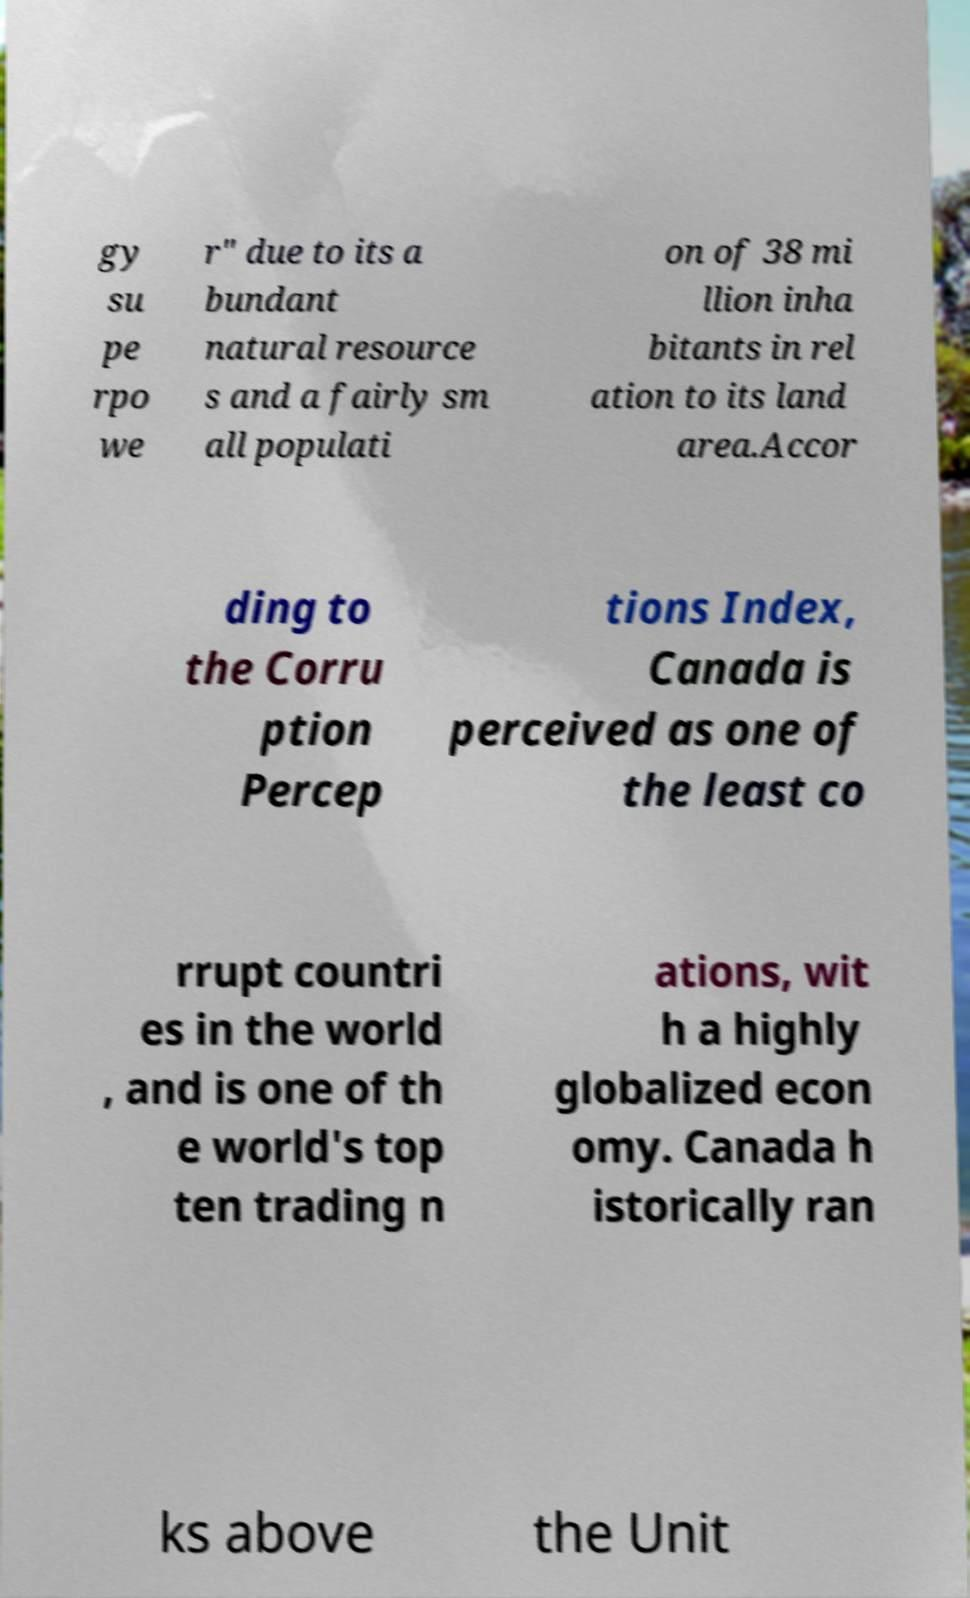There's text embedded in this image that I need extracted. Can you transcribe it verbatim? gy su pe rpo we r" due to its a bundant natural resource s and a fairly sm all populati on of 38 mi llion inha bitants in rel ation to its land area.Accor ding to the Corru ption Percep tions Index, Canada is perceived as one of the least co rrupt countri es in the world , and is one of th e world's top ten trading n ations, wit h a highly globalized econ omy. Canada h istorically ran ks above the Unit 